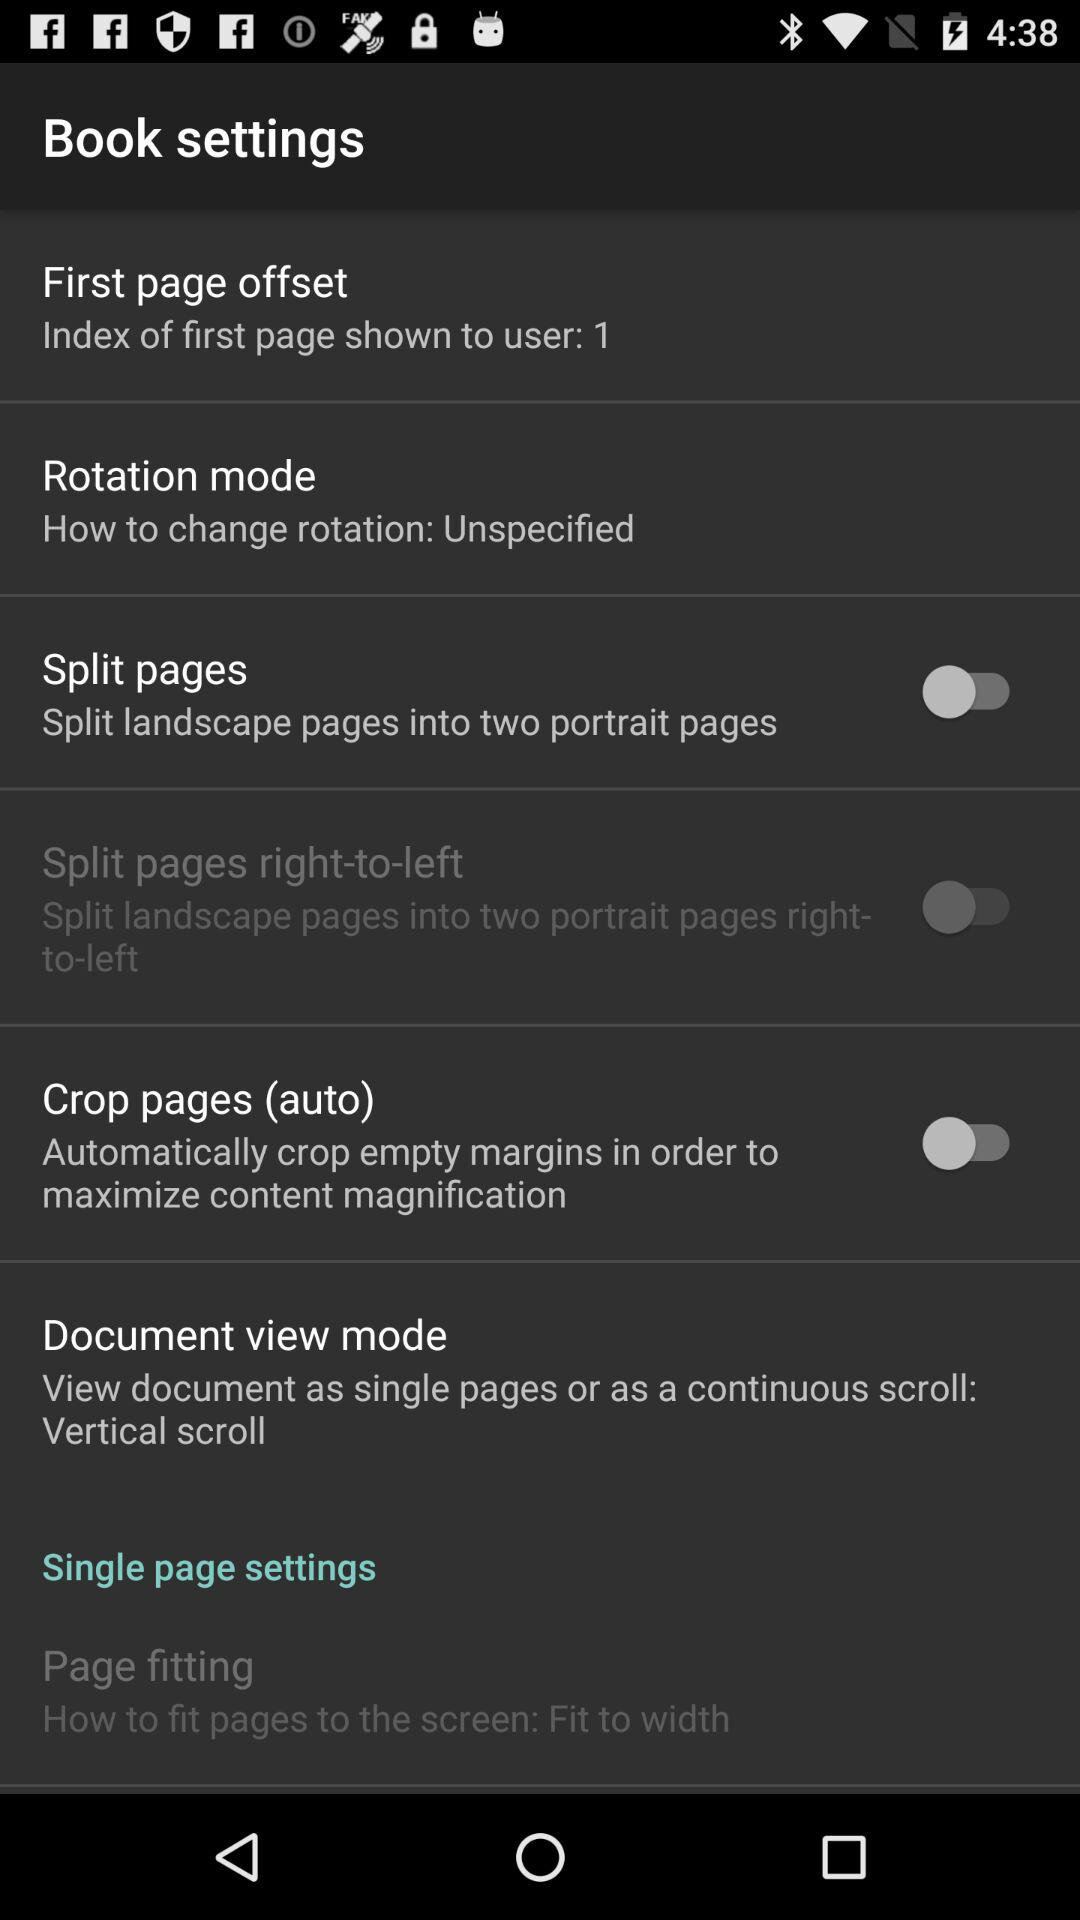What is the status of "Crop pages (auto)"? The status is "off". 